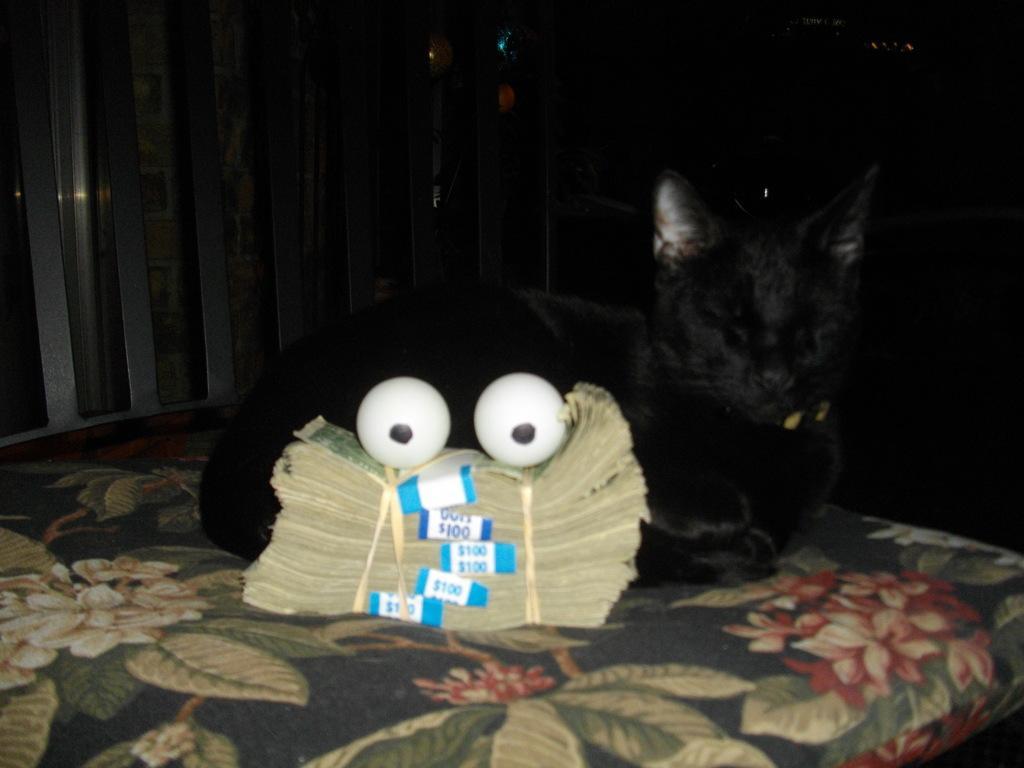How would you summarize this image in a sentence or two? In the center of the picture there are currency notes, eyeballs and a cat on a bed. In the background there are balloons and an iron object. 